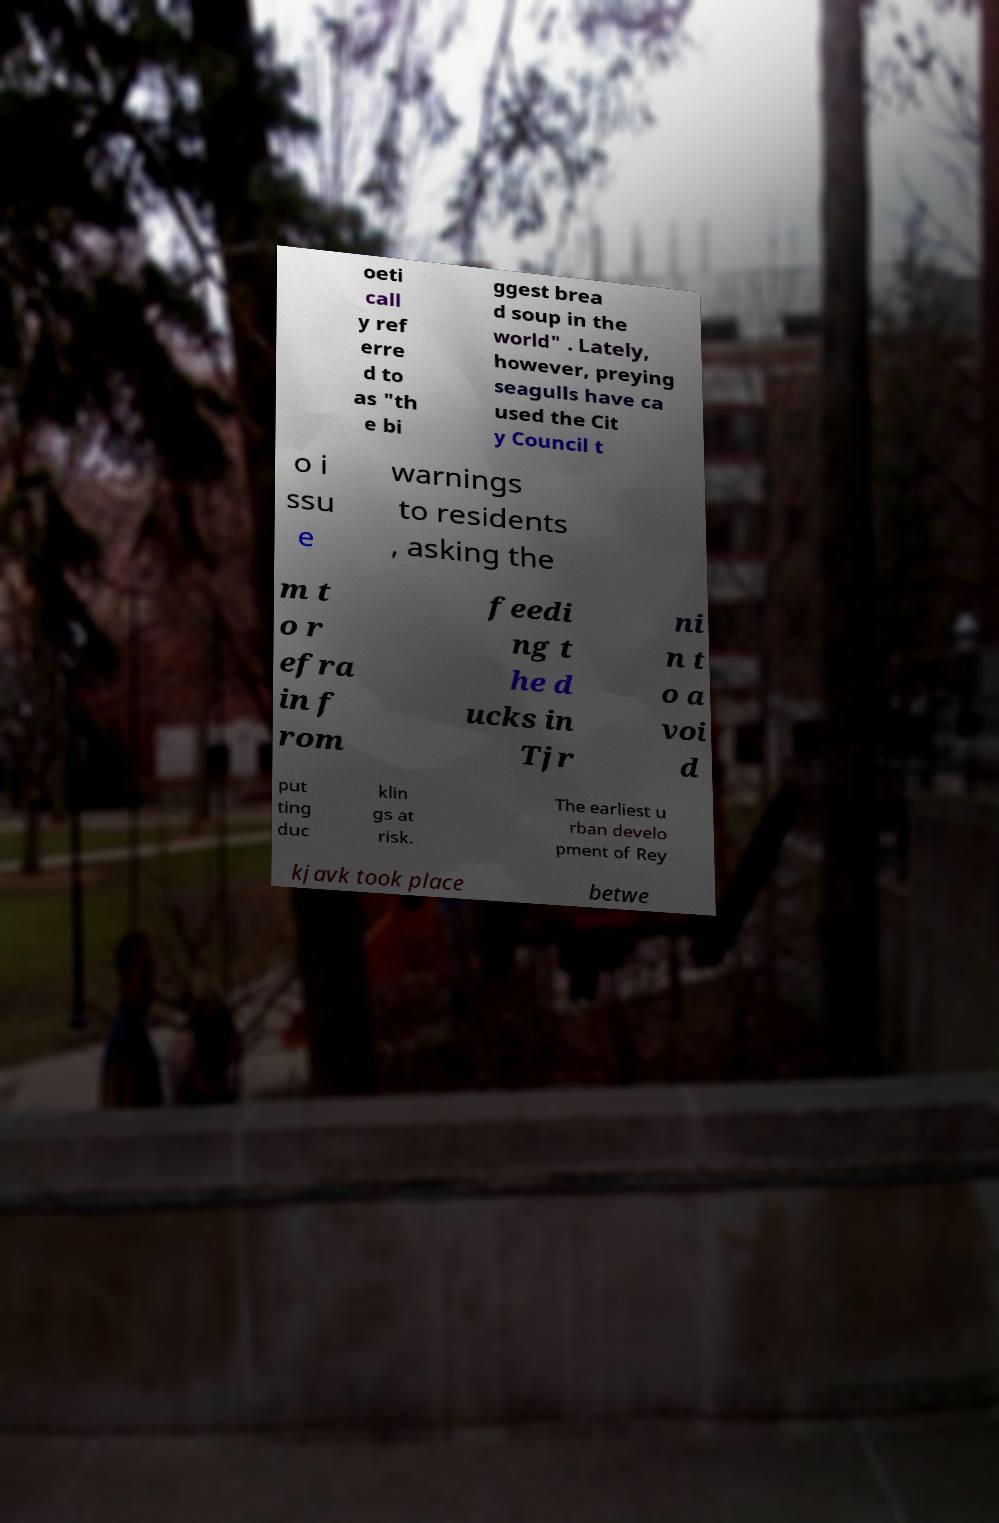Could you assist in decoding the text presented in this image and type it out clearly? oeti call y ref erre d to as "th e bi ggest brea d soup in the world" . Lately, however, preying seagulls have ca used the Cit y Council t o i ssu e warnings to residents , asking the m t o r efra in f rom feedi ng t he d ucks in Tjr ni n t o a voi d put ting duc klin gs at risk. The earliest u rban develo pment of Rey kjavk took place betwe 